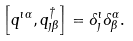<formula> <loc_0><loc_0><loc_500><loc_500>\left [ q ^ { \imath \alpha } , q ^ { \dagger } _ { \jmath \beta } \right ] = \delta ^ { \imath } _ { \jmath } \delta ^ { \alpha } _ { \beta } .</formula> 